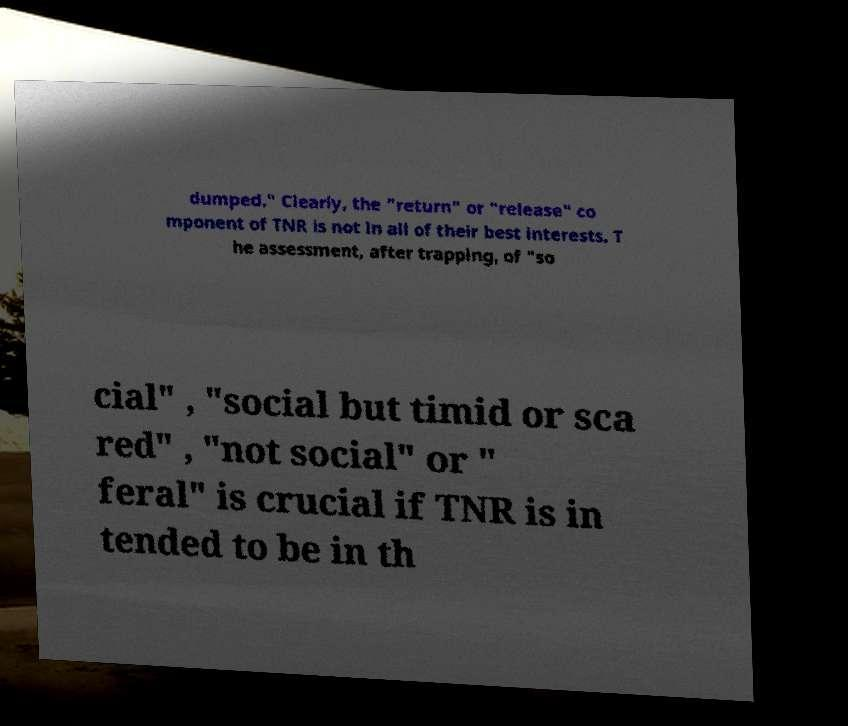Please read and relay the text visible in this image. What does it say? dumped." Clearly, the "return" or "release" co mponent of TNR is not in all of their best interests. T he assessment, after trapping, of "so cial" , "social but timid or sca red" , "not social" or " feral" is crucial if TNR is in tended to be in th 